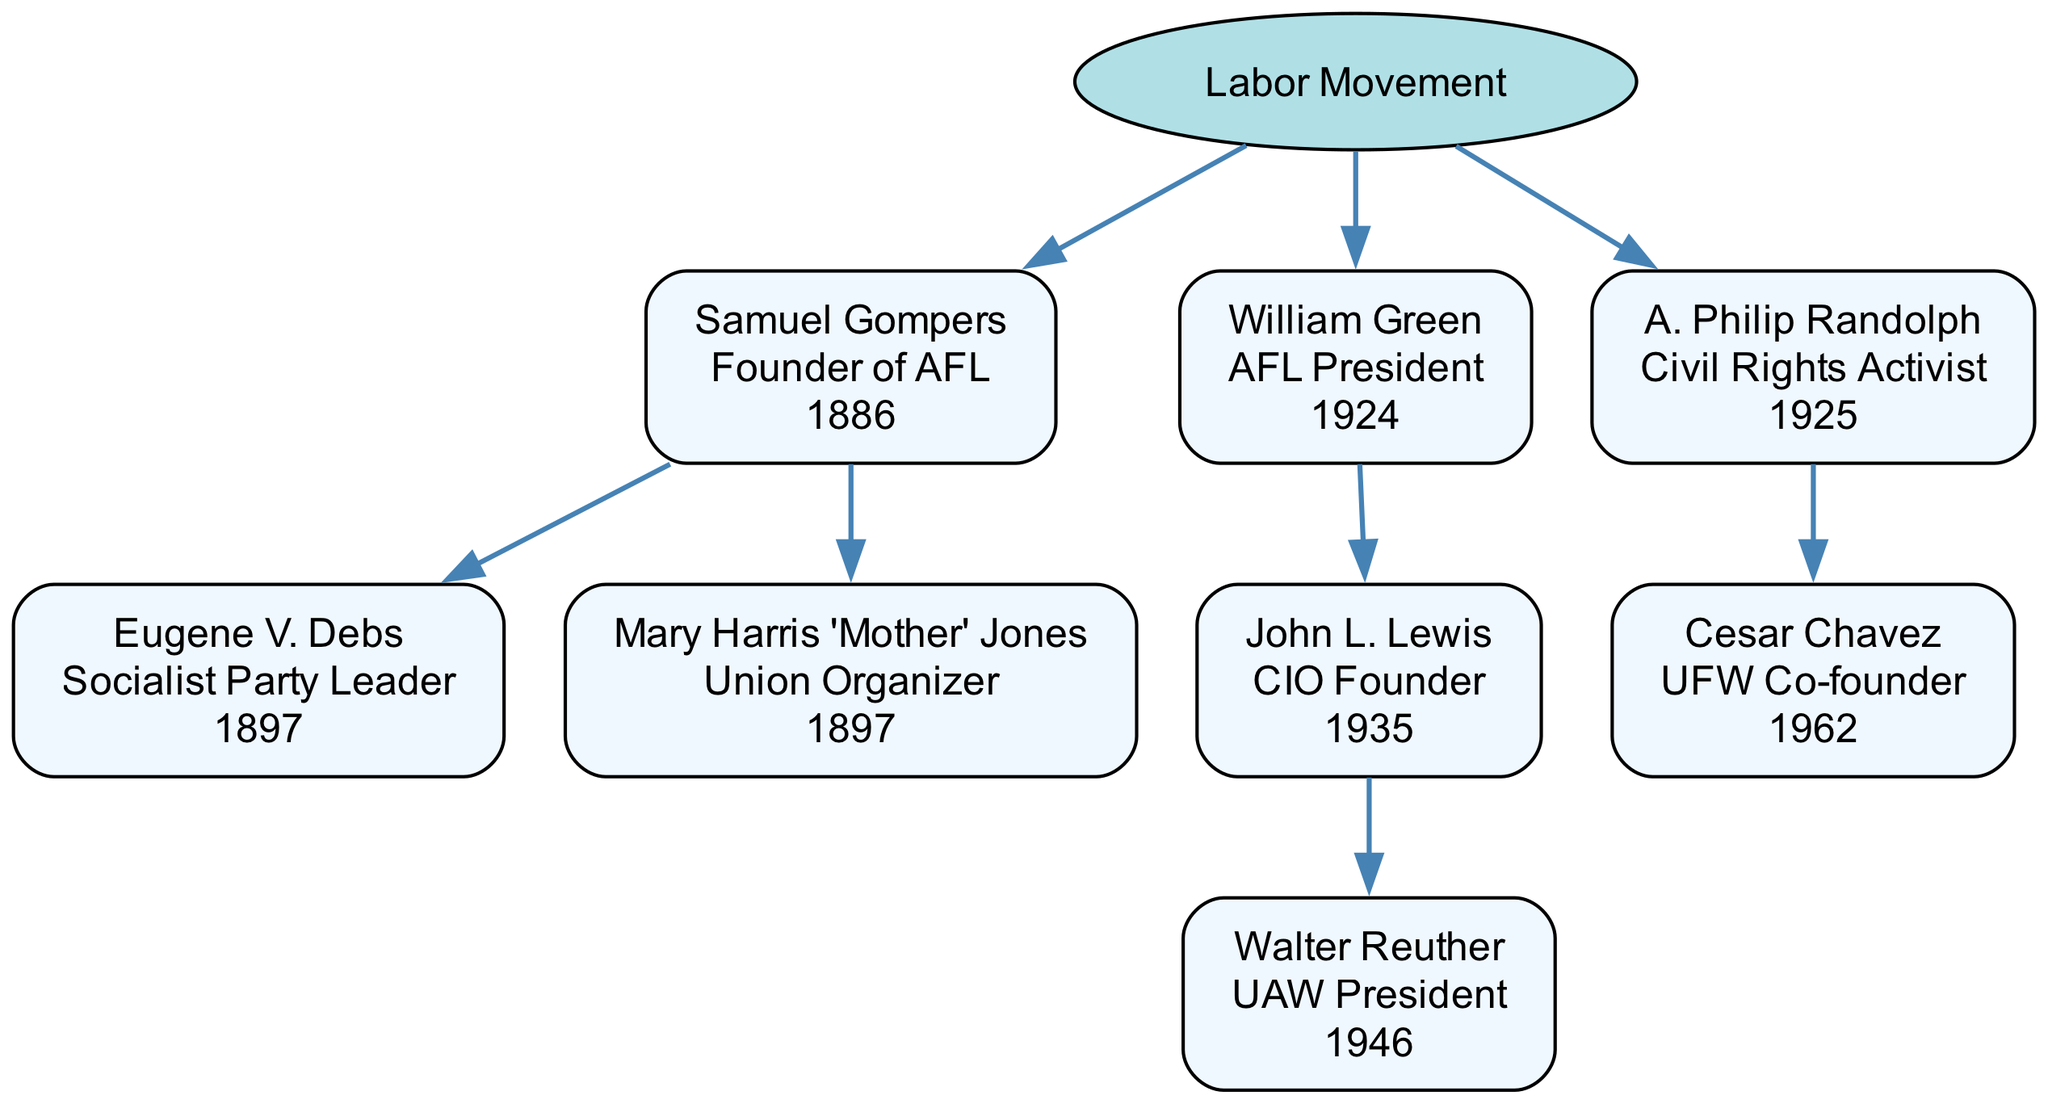What is the role of Samuel Gompers? In the diagram, Samuel Gompers is indicated as the "Founder of AFL," which is clearly stated next to his name in the node.
Answer: Founder of AFL Who is the parent of Eugene V. Debs? Eugene V. Debs is a child of Samuel Gompers, as depicted in the diagram with a connecting edge showing the relationship between them.
Answer: Samuel Gompers How many children does William Green have? The diagram illustrates that William Green has one child, which is John L. Lewis, connected directly below him.
Answer: 1 What year did John L. Lewis found the CIO? The diagram shows that John L. Lewis founded the CIO in the year "1935," which is written in his node.
Answer: 1935 Who is the Union Organizer listed under Samuel Gompers? The diagram clearly states that Mary Harris 'Mother' Jones is a "Union Organizer," positioned as a child node under Samuel Gompers.
Answer: Mary Harris 'Mother' Jones What is the relationship between A. Philip Randolph and Cesar Chavez? A. Philip Randolph is the parent of Cesar Chavez, as indicated in the diagram by the edge connecting Randolph to Chavez.
Answer: Parent-Child How does the role of William Green compare to that of A. Philip Randolph? William Green is labeled as "AFL President," while A. Philip Randolph is labeled as "Civil Rights Activist," showing they hold different roles in their respective nodes.
Answer: Different roles What role did Walter Reuther serve? The role associated with Walter Reuther is "UAW President," which is specifically mentioned in his node within the diagram.
Answer: UAW President How many people are there at the same level as Samuel Gompers? At the same level as Samuel Gompers, there are three individuals (Gompers, William Green, and A. Philip Randolph), as they are all directly beneath the "Labor Movement" root.
Answer: 3 